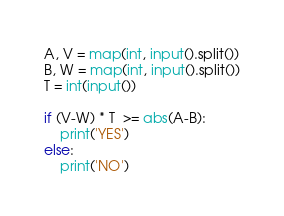Convert code to text. <code><loc_0><loc_0><loc_500><loc_500><_Python_>A, V = map(int, input().split())
B, W = map(int, input().split())
T = int(input())

if (V-W) * T  >= abs(A-B):
    print('YES')
else:
    print('NO')
</code> 